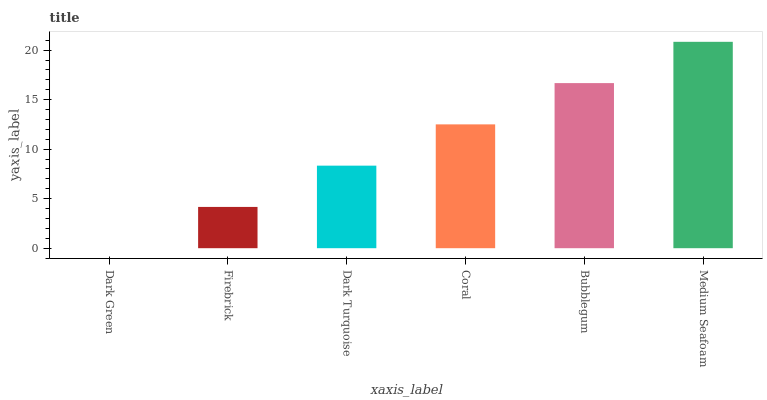Is Dark Green the minimum?
Answer yes or no. Yes. Is Medium Seafoam the maximum?
Answer yes or no. Yes. Is Firebrick the minimum?
Answer yes or no. No. Is Firebrick the maximum?
Answer yes or no. No. Is Firebrick greater than Dark Green?
Answer yes or no. Yes. Is Dark Green less than Firebrick?
Answer yes or no. Yes. Is Dark Green greater than Firebrick?
Answer yes or no. No. Is Firebrick less than Dark Green?
Answer yes or no. No. Is Coral the high median?
Answer yes or no. Yes. Is Dark Turquoise the low median?
Answer yes or no. Yes. Is Bubblegum the high median?
Answer yes or no. No. Is Dark Green the low median?
Answer yes or no. No. 